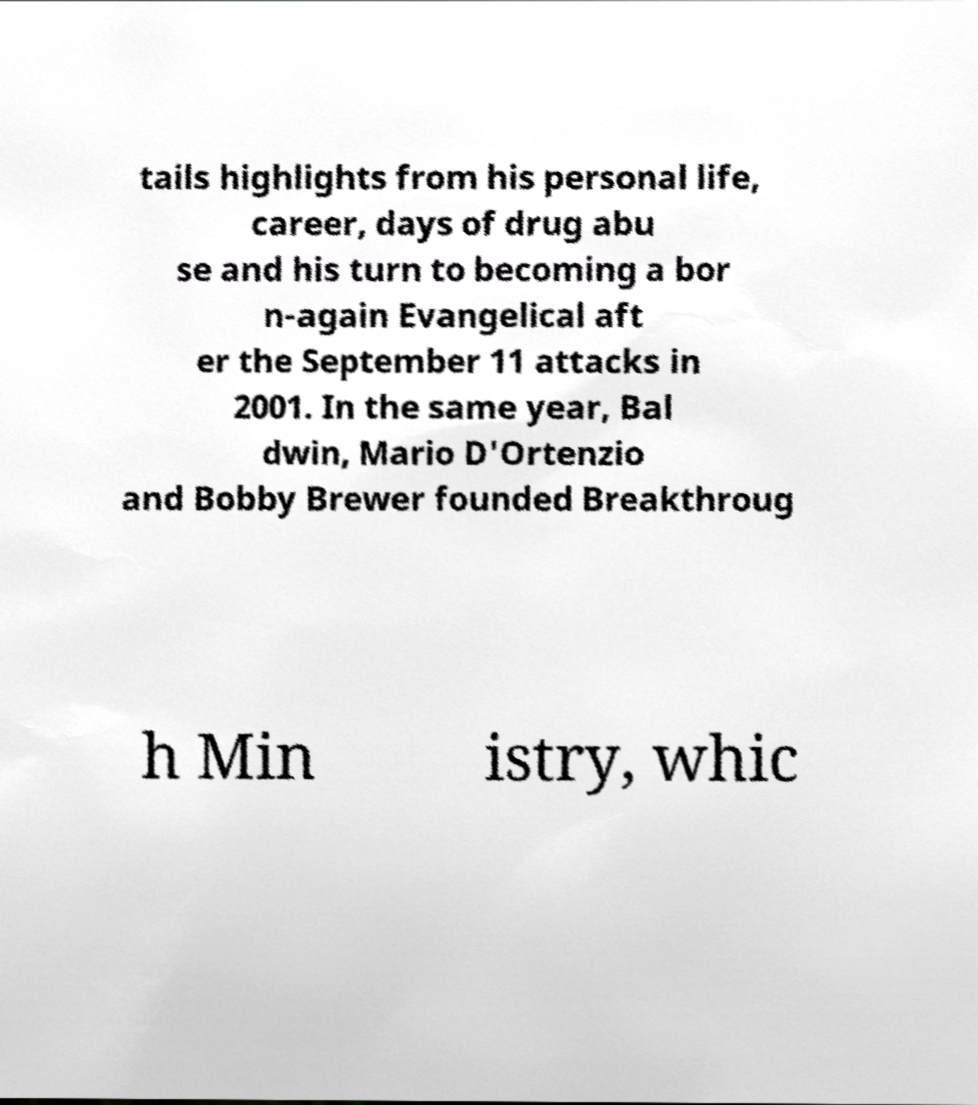Can you read and provide the text displayed in the image?This photo seems to have some interesting text. Can you extract and type it out for me? tails highlights from his personal life, career, days of drug abu se and his turn to becoming a bor n-again Evangelical aft er the September 11 attacks in 2001. In the same year, Bal dwin, Mario D'Ortenzio and Bobby Brewer founded Breakthroug h Min istry, whic 